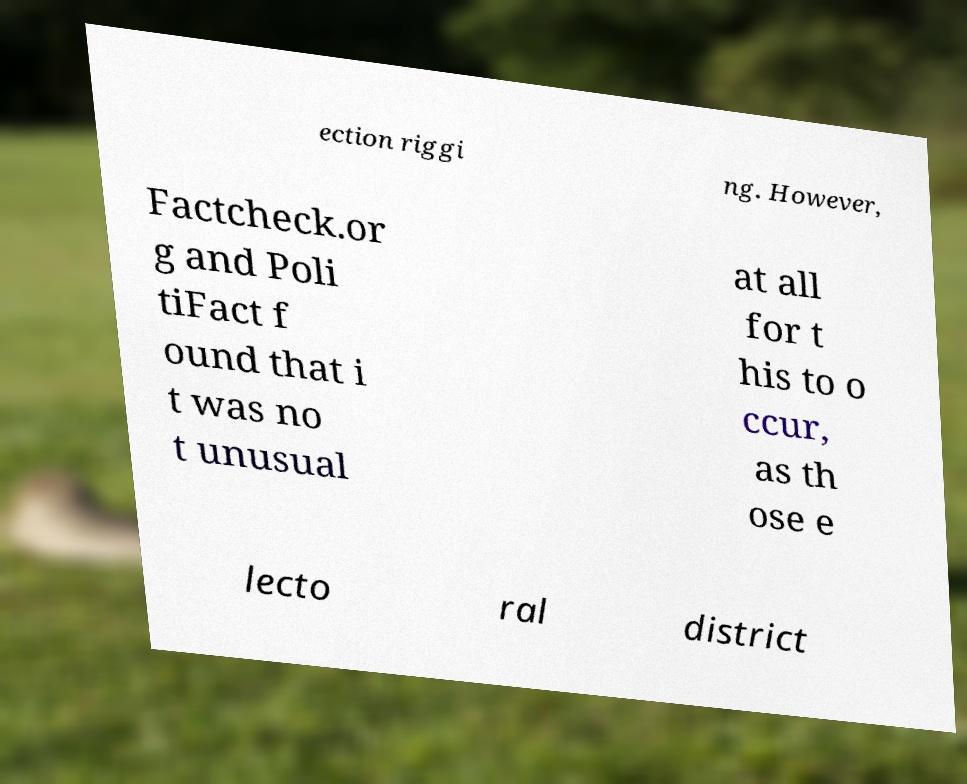Please read and relay the text visible in this image. What does it say? ection riggi ng. However, Factcheck.or g and Poli tiFact f ound that i t was no t unusual at all for t his to o ccur, as th ose e lecto ral district 